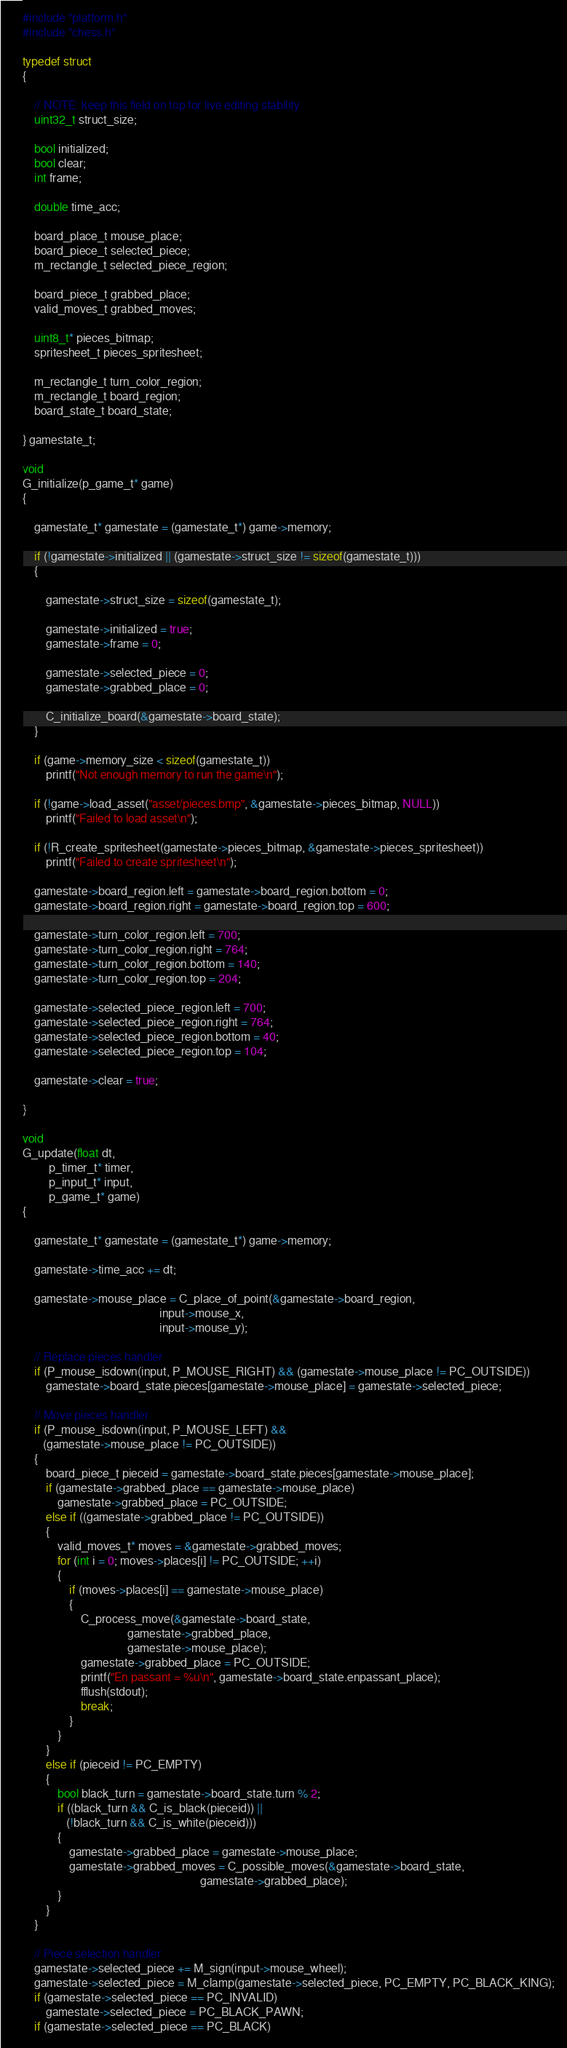Convert code to text. <code><loc_0><loc_0><loc_500><loc_500><_C_>#include "platform.h"
#include "chess.h"

typedef struct
{

    // NOTE: keep this field on top for live editing stability
    uint32_t struct_size;

    bool initialized;
    bool clear;
    int frame;

    double time_acc;

    board_place_t mouse_place;
    board_piece_t selected_piece;
    m_rectangle_t selected_piece_region;

    board_piece_t grabbed_place;
    valid_moves_t grabbed_moves;

    uint8_t* pieces_bitmap;
    spritesheet_t pieces_spritesheet;

    m_rectangle_t turn_color_region;
    m_rectangle_t board_region;
    board_state_t board_state;

} gamestate_t;

void
G_initialize(p_game_t* game)
{

    gamestate_t* gamestate = (gamestate_t*) game->memory;

    if (!gamestate->initialized || (gamestate->struct_size != sizeof(gamestate_t)))
    {

        gamestate->struct_size = sizeof(gamestate_t);

        gamestate->initialized = true;
        gamestate->frame = 0;

        gamestate->selected_piece = 0;
        gamestate->grabbed_place = 0;

        C_initialize_board(&gamestate->board_state);
    }

    if (game->memory_size < sizeof(gamestate_t))
        printf("Not enough memory to run the game\n");

    if (!game->load_asset("asset/pieces.bmp", &gamestate->pieces_bitmap, NULL))
        printf("Failed to load asset\n");

    if (!R_create_spritesheet(gamestate->pieces_bitmap, &gamestate->pieces_spritesheet))
        printf("Failed to create spritesheet\n");

    gamestate->board_region.left = gamestate->board_region.bottom = 0;
    gamestate->board_region.right = gamestate->board_region.top = 600;
    
    gamestate->turn_color_region.left = 700;
    gamestate->turn_color_region.right = 764;
    gamestate->turn_color_region.bottom = 140;
    gamestate->turn_color_region.top = 204;

    gamestate->selected_piece_region.left = 700;
    gamestate->selected_piece_region.right = 764;
    gamestate->selected_piece_region.bottom = 40;
    gamestate->selected_piece_region.top = 104;

    gamestate->clear = true;

}

void
G_update(float dt,
         p_timer_t* timer,
         p_input_t* input,
         p_game_t* game)
{

    gamestate_t* gamestate = (gamestate_t*) game->memory;

    gamestate->time_acc += dt;

    gamestate->mouse_place = C_place_of_point(&gamestate->board_region,
                                               input->mouse_x,
                                               input->mouse_y);

    // Replace pieces handler
    if (P_mouse_isdown(input, P_MOUSE_RIGHT) && (gamestate->mouse_place != PC_OUTSIDE))
        gamestate->board_state.pieces[gamestate->mouse_place] = gamestate->selected_piece;

    // Move pieces handler
    if (P_mouse_isdown(input, P_MOUSE_LEFT) &&
       (gamestate->mouse_place != PC_OUTSIDE))
    {
        board_piece_t pieceid = gamestate->board_state.pieces[gamestate->mouse_place];
        if (gamestate->grabbed_place == gamestate->mouse_place)
            gamestate->grabbed_place = PC_OUTSIDE;
        else if ((gamestate->grabbed_place != PC_OUTSIDE))
        {
            valid_moves_t* moves = &gamestate->grabbed_moves;
            for (int i = 0; moves->places[i] != PC_OUTSIDE; ++i)
            {
                if (moves->places[i] == gamestate->mouse_place)
                {
                    C_process_move(&gamestate->board_state,
                                    gamestate->grabbed_place,
                                    gamestate->mouse_place);
                    gamestate->grabbed_place = PC_OUTSIDE;
                    printf("En passant = %u\n", gamestate->board_state.enpassant_place);
                    fflush(stdout);
                    break;
                }
            }
        }
        else if (pieceid != PC_EMPTY)
        {
            bool black_turn = gamestate->board_state.turn % 2;
            if ((black_turn && C_is_black(pieceid)) ||
               (!black_turn && C_is_white(pieceid)))
            {
                gamestate->grabbed_place = gamestate->mouse_place;
                gamestate->grabbed_moves = C_possible_moves(&gamestate->board_state,
                                                             gamestate->grabbed_place);                
            }
        }
    }

    // Piece selection handler
    gamestate->selected_piece += M_sign(input->mouse_wheel);
    gamestate->selected_piece = M_clamp(gamestate->selected_piece, PC_EMPTY, PC_BLACK_KING);
    if (gamestate->selected_piece == PC_INVALID)
        gamestate->selected_piece = PC_BLACK_PAWN;
    if (gamestate->selected_piece == PC_BLACK)</code> 